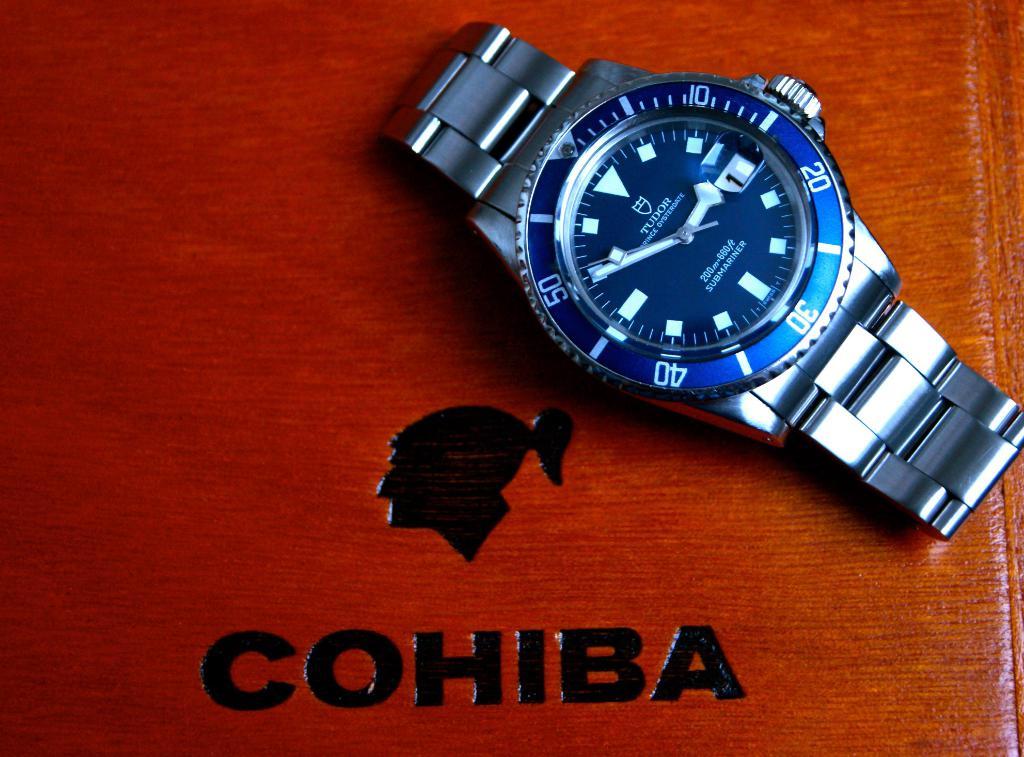What is the name on the box?
Provide a succinct answer. Cohiba. 